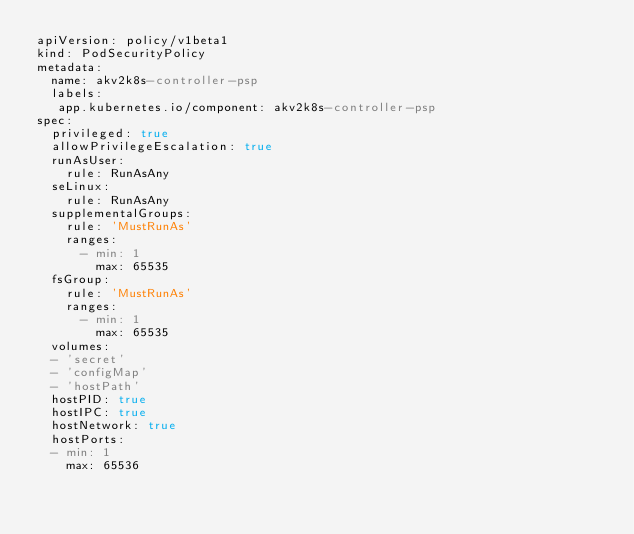Convert code to text. <code><loc_0><loc_0><loc_500><loc_500><_YAML_>apiVersion: policy/v1beta1
kind: PodSecurityPolicy
metadata:
  name: akv2k8s-controller-psp
  labels:
   app.kubernetes.io/component: akv2k8s-controller-psp
spec:
  privileged: true
  allowPrivilegeEscalation: true
  runAsUser:
    rule: RunAsAny
  seLinux:
    rule: RunAsAny
  supplementalGroups:
    rule: 'MustRunAs'
    ranges:
      - min: 1
        max: 65535
  fsGroup:
    rule: 'MustRunAs'
    ranges:
      - min: 1
        max: 65535
  volumes:
  - 'secret'
  - 'configMap'
  - 'hostPath'
  hostPID: true
  hostIPC: true
  hostNetwork: true
  hostPorts:
  - min: 1
    max: 65536</code> 